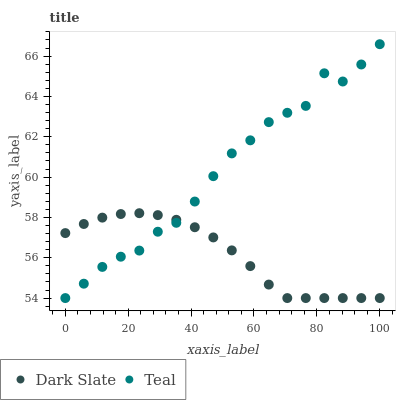Does Dark Slate have the minimum area under the curve?
Answer yes or no. Yes. Does Teal have the maximum area under the curve?
Answer yes or no. Yes. Does Teal have the minimum area under the curve?
Answer yes or no. No. Is Dark Slate the smoothest?
Answer yes or no. Yes. Is Teal the roughest?
Answer yes or no. Yes. Is Teal the smoothest?
Answer yes or no. No. Does Dark Slate have the lowest value?
Answer yes or no. Yes. Does Teal have the highest value?
Answer yes or no. Yes. Does Teal intersect Dark Slate?
Answer yes or no. Yes. Is Teal less than Dark Slate?
Answer yes or no. No. Is Teal greater than Dark Slate?
Answer yes or no. No. 